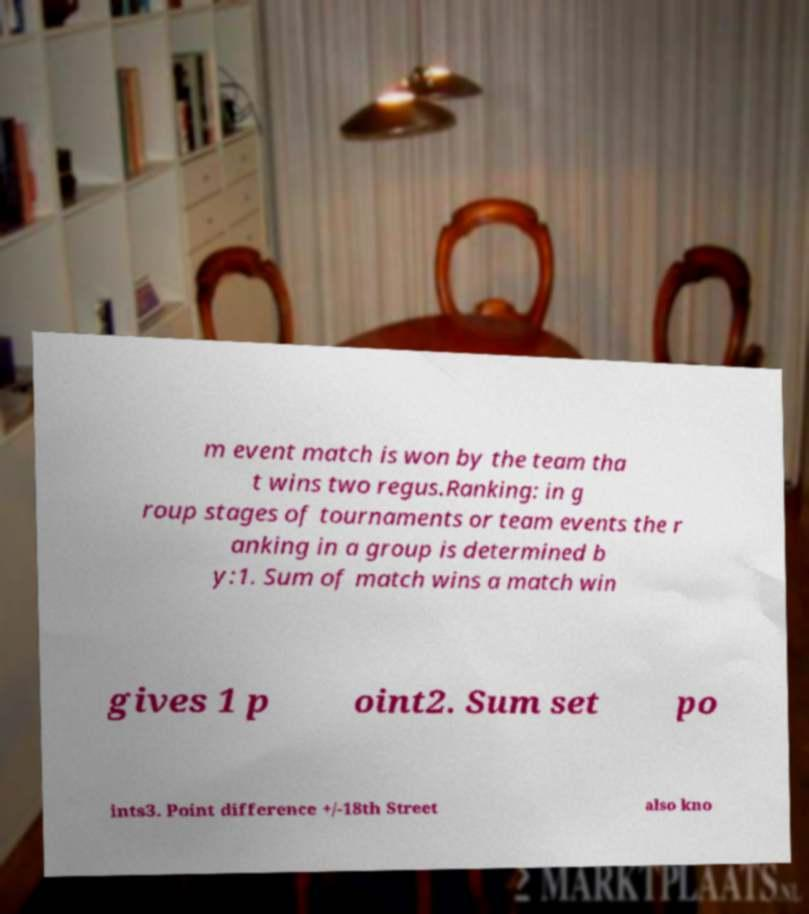Can you accurately transcribe the text from the provided image for me? m event match is won by the team tha t wins two regus.Ranking: in g roup stages of tournaments or team events the r anking in a group is determined b y:1. Sum of match wins a match win gives 1 p oint2. Sum set po ints3. Point difference +/-18th Street also kno 